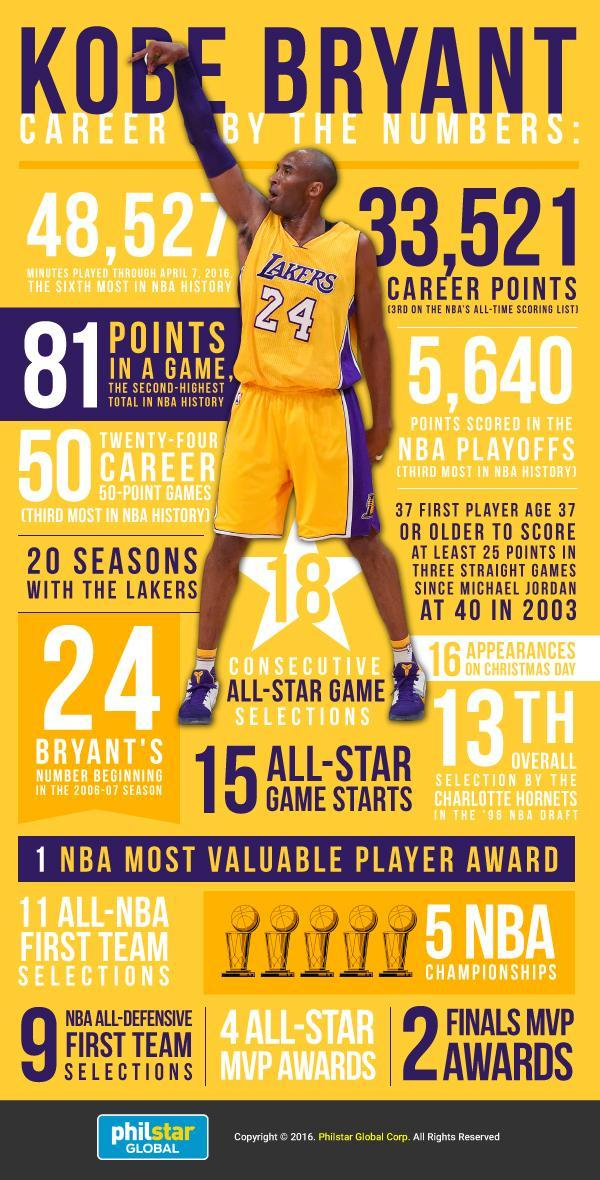How many trophies have been displayed
Answer the question with a short phrase. 5 What is the number on the T shirt 24 how many points scored in the NBA playoffs 5,640 which team is Kobe Bryant in Lakers How many consecutive all-star game selections 18 How many minutes played through April 7, 2016 48,527 